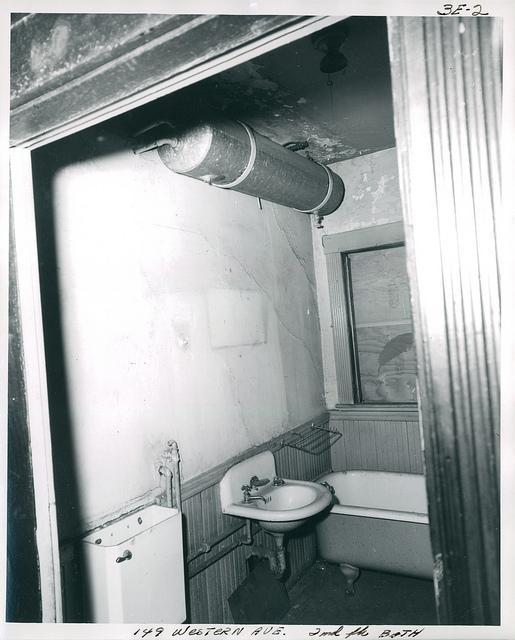How many sinks are there?
Give a very brief answer. 1. 